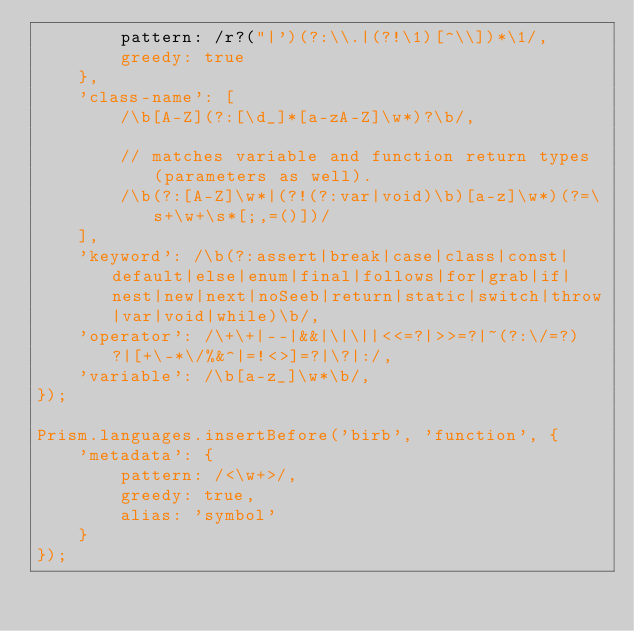Convert code to text. <code><loc_0><loc_0><loc_500><loc_500><_JavaScript_>		pattern: /r?("|')(?:\\.|(?!\1)[^\\])*\1/,
		greedy: true
	},
	'class-name': [
		/\b[A-Z](?:[\d_]*[a-zA-Z]\w*)?\b/,

		// matches variable and function return types (parameters as well).
		/\b(?:[A-Z]\w*|(?!(?:var|void)\b)[a-z]\w*)(?=\s+\w+\s*[;,=()])/
	],
	'keyword': /\b(?:assert|break|case|class|const|default|else|enum|final|follows|for|grab|if|nest|new|next|noSeeb|return|static|switch|throw|var|void|while)\b/,
	'operator': /\+\+|--|&&|\|\||<<=?|>>=?|~(?:\/=?)?|[+\-*\/%&^|=!<>]=?|\?|:/,
	'variable': /\b[a-z_]\w*\b/,
});

Prism.languages.insertBefore('birb', 'function', {
	'metadata': {
		pattern: /<\w+>/,
		greedy: true,
		alias: 'symbol'
	}
});
</code> 